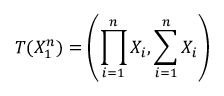<formula> <loc_0><loc_0><loc_500><loc_500>T ( X _ { 1 } ^ { n } ) = \left ( \prod _ { i = 1 } ^ { n } X _ { i } , \sum _ { i = 1 } ^ { n } X _ { i } \right )</formula> 